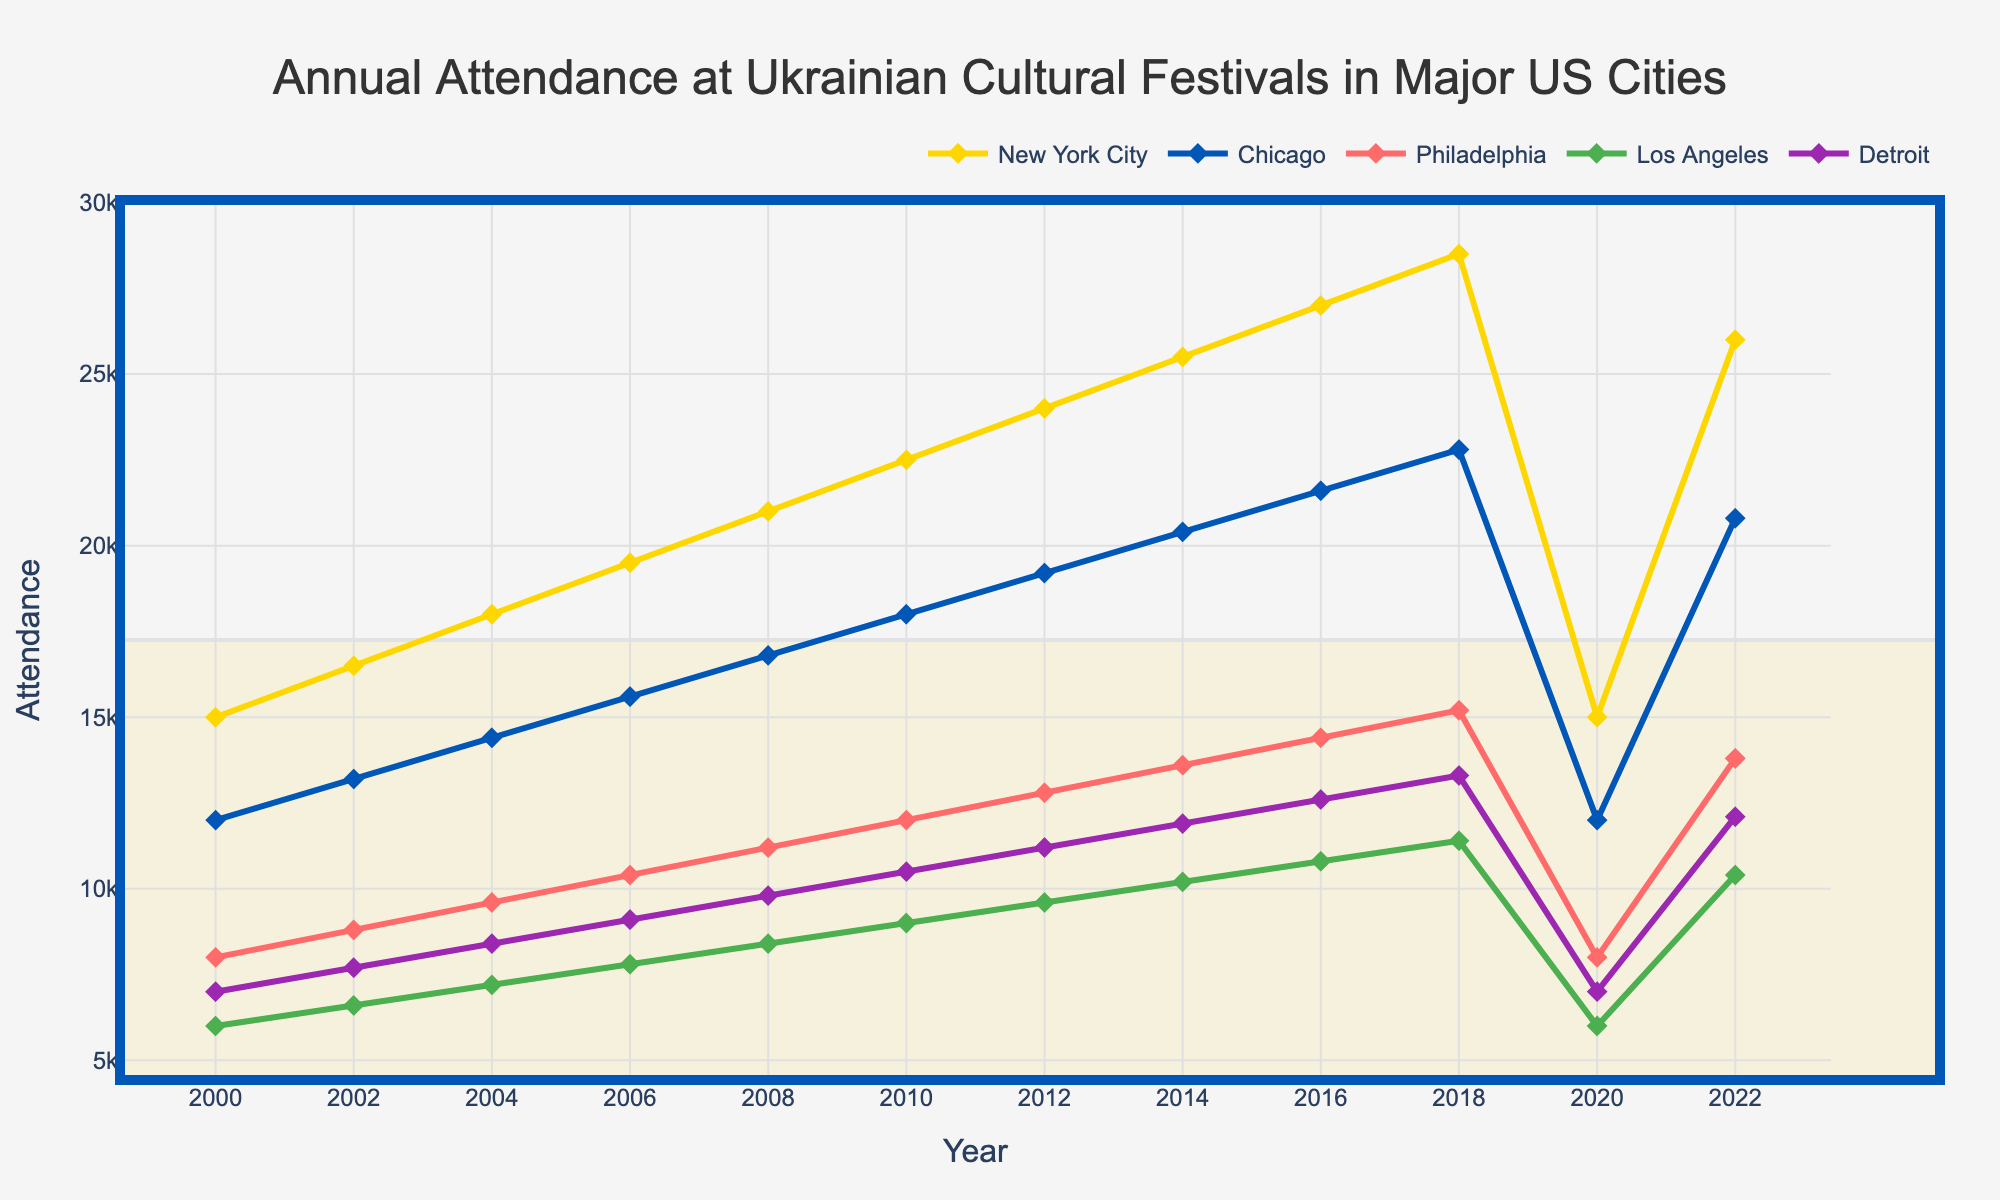Which city had the highest festival attendance in 2018? Look for the highest data point in 2018 and identify the city corresponding to this data point. For 2018, New York City's attendance was 28,500, which is the highest.
Answer: New York City How did the attendance in Detroit change from 2000 to 2010? Note the attendance numbers in Detroit for 2000 and 2010 and calculate the change. In 2000, it was 7,000, and by 2010, it increased to 10,500. Therefore, the change is 10,500 - 7,000 = 3,500.
Answer: Increased by 3,500 Which city saw the least attendance decline between 2018 and 2020? Compare the attendance figures for each city between 2018 and 2020 and identify the smallest decline. New York City dropped from 28,500 to 15,000, Chicago from 22,800 to 12,000, Philadelphia from 15,200 to 8,000, Los Angeles from 11,400 to 6,000, and Detroit from 13,300 to 7,000. Chicago saw a decline of 10,800, the smallest among other cities.
Answer: Chicago What is the average attendance in Philadelphia from 2000 to 2022? Sum up all Philadelphia's attendance numbers from every year and then divide by the count of years. The attendance numbers are 8,000, 8,800, 9,600, 10,400, 11,200, 12,000, 12,800, 13,600, 14,400, 15,200, 8,000, and 13,800. The sum is 138,800, and there are 12 years, so the average is 138,800 / 12 = 11,566.67.
Answer: 11,566.67 Which year experienced the steepest increase in festival attendance in Los Angeles? Identify the year-over-year change for Los Angeles, and the steepest increase will be the largest difference. From the data: 
2000 to 2002: 6,600 - 6,000 = 600,
2002 to 2004: 7,200 - 6,600 = 600,
2004 to 2006: 7,800 - 7,200 = 600,
2006 to 2008: 8,400 - 7,800 = 600,
2008 to 2010: 9,000 - 8,400 = 600,
2010 to 2012: 9,600 - 9,000 = 600,
2012 to 2014: 10,200 - 9,600 = 600,
2014 to 2016: 10,800 - 10,200 = 600,
2016 to 2018: 11,400 - 10,800 = 600,
2018 to 2020: 6,000 - 11,400 = -5,400,
2020 to 2022: 10,400 - 6,000 = 4,400.
The steepest increase happened between 2020 and 2022, with an increase of 4,400.
Answer: 2020 to 2022 What is the total attendance across all cities for the year 2006? Add up the attendance across all cities for the year 2006. The numbers are 19,500 (NYC), 15,600 (Chicago), 10,400 (Philadelphia), 7,800 (LA), and 9,100 (Detroit), for a total of 19,500 + 15,600 + 10,400 + 7,800 + 9,100 = 62,400.
Answer: 62,400 Between which two consecutive years did Philadelphia see the greatest increase in attendance? Calculate the year-over-year increases for Philadelphia. From the data: 
2000 to 2002: 8,800 - 8,000 = 800,
2002 to 2004: 9,600 - 8,800 = 800,
2004 to 2006: 10,400 - 9,600 = 800,
2006 to 2008: 11,200 - 10,400 = 800,
2008 to 2010: 12,000 - 11,200 = 800,
2010 to 2012: 12,800 - 12,000 = 800,
2012 to 2014: 13,600 - 12,800 = 800,
2014 to 2016: 14,400 - 13,600 = 800,
2016 to 2018: 15,200 - 14,400 = 800,
2018 to 2020: 8,000 - 15,200 = -7,200,
2020 to 2022: 13,800 - 8,000 = 5,800.
The greatest increase happened between 2020 and 2022 with an increase of 5,800.
Answer: 2020 to 2022 